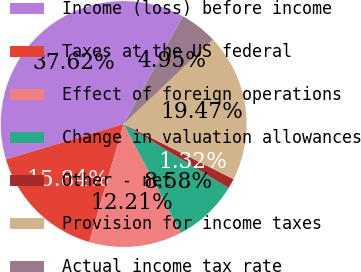Convert chart. <chart><loc_0><loc_0><loc_500><loc_500><pie_chart><fcel>Income (loss) before income<fcel>Taxes at the US federal<fcel>Effect of foreign operations<fcel>Change in valuation allowances<fcel>Other - net<fcel>Provision for income taxes<fcel>Actual income tax rate<nl><fcel>37.62%<fcel>15.84%<fcel>12.21%<fcel>8.58%<fcel>1.32%<fcel>19.47%<fcel>4.95%<nl></chart> 